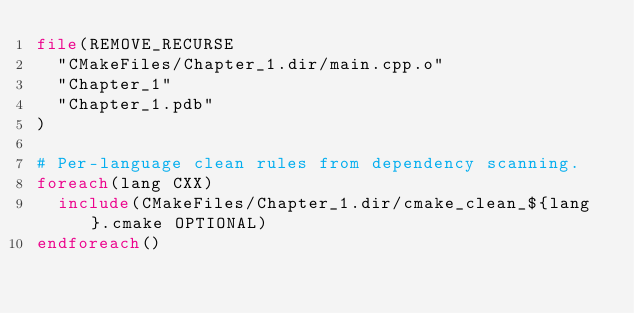Convert code to text. <code><loc_0><loc_0><loc_500><loc_500><_CMake_>file(REMOVE_RECURSE
  "CMakeFiles/Chapter_1.dir/main.cpp.o"
  "Chapter_1"
  "Chapter_1.pdb"
)

# Per-language clean rules from dependency scanning.
foreach(lang CXX)
  include(CMakeFiles/Chapter_1.dir/cmake_clean_${lang}.cmake OPTIONAL)
endforeach()
</code> 